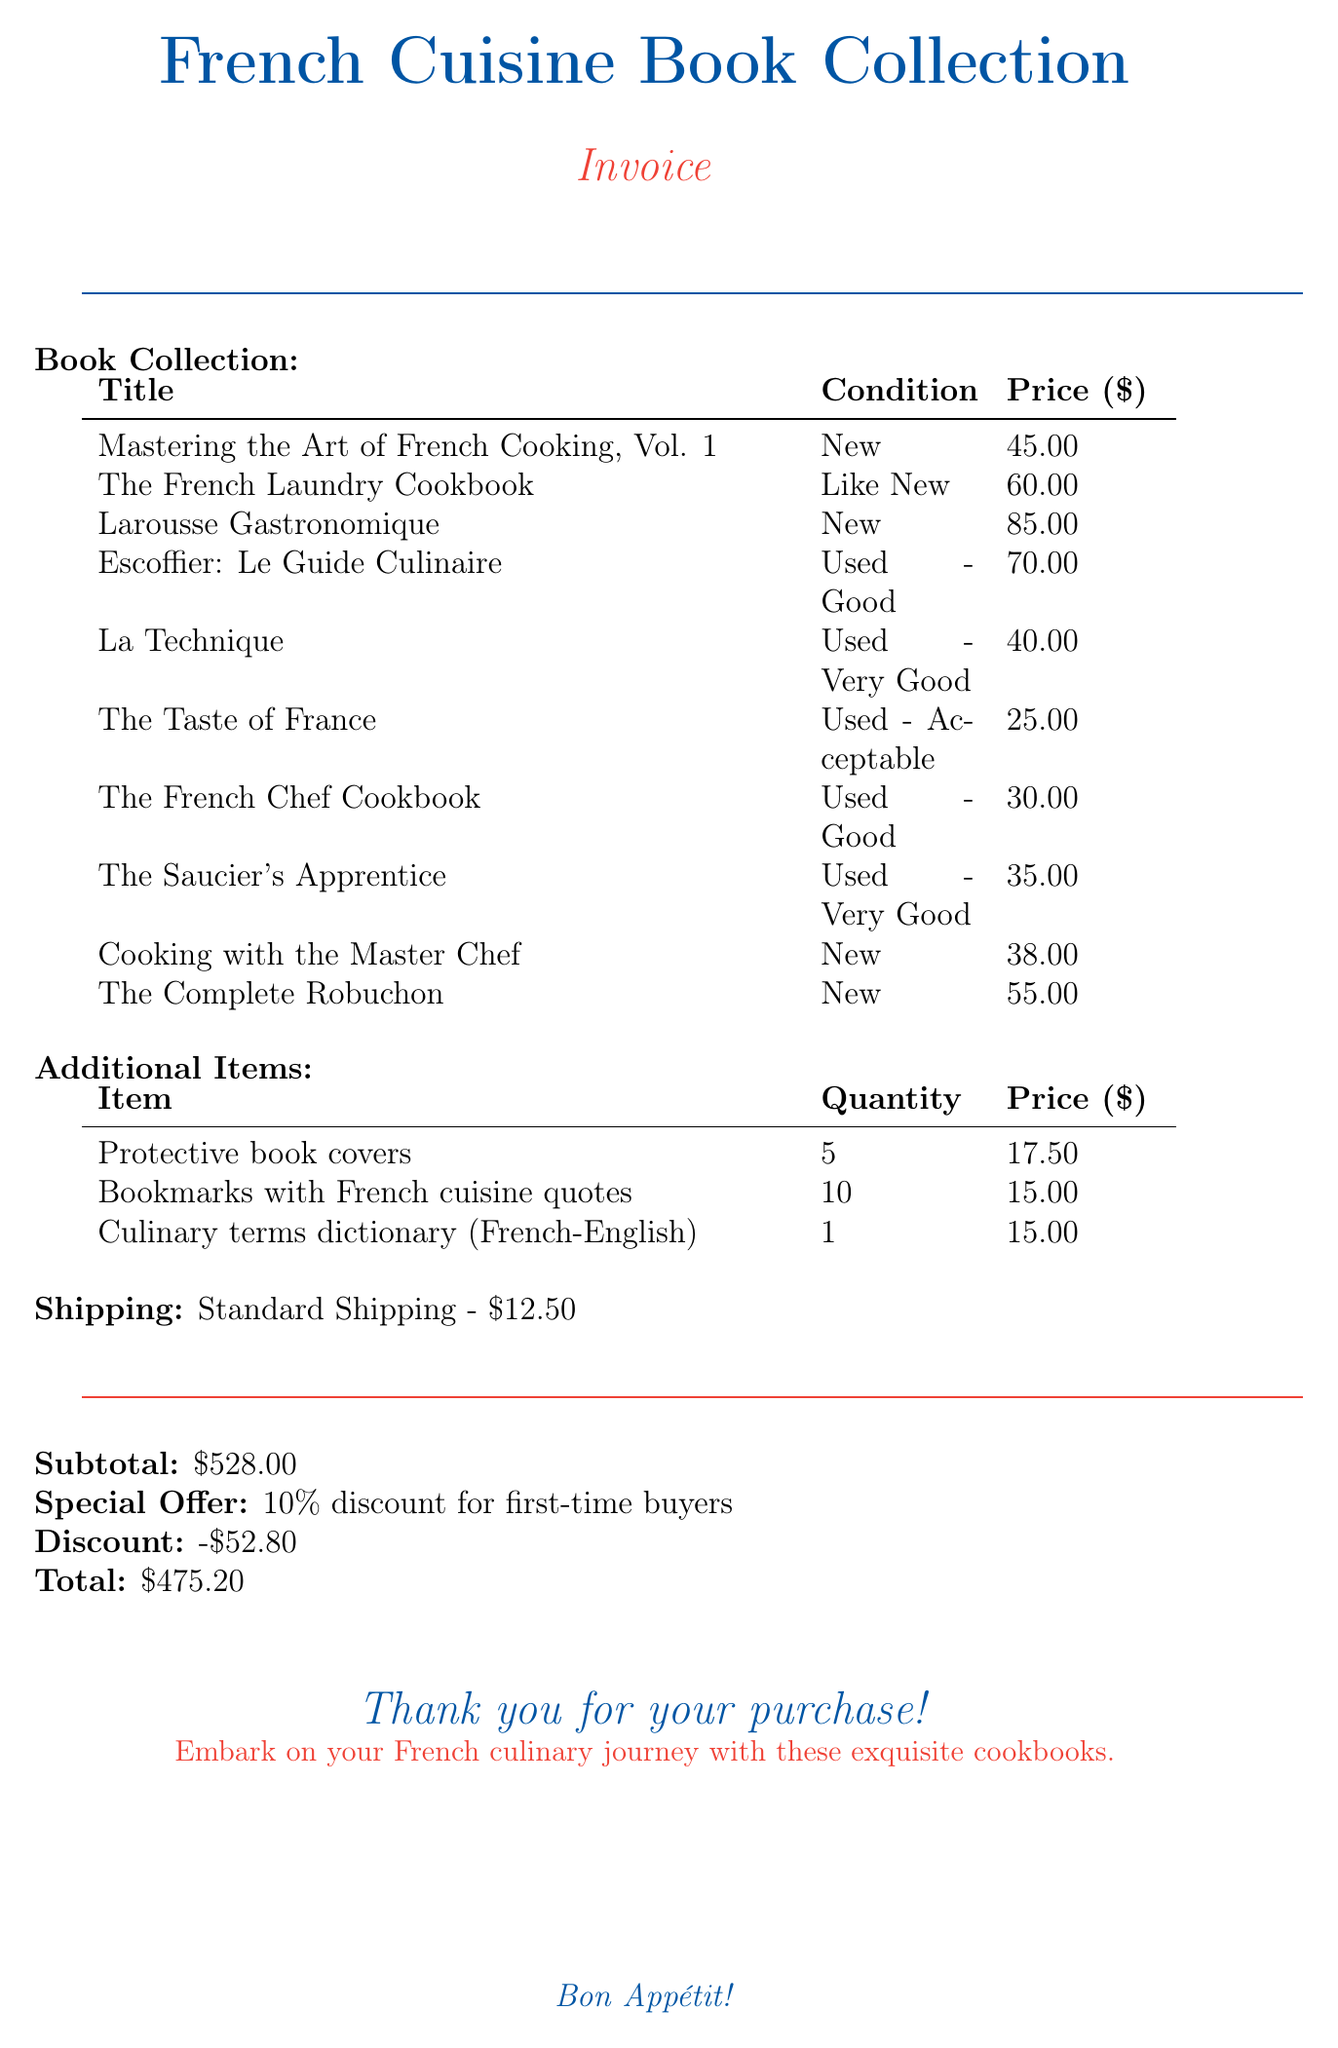What is the total amount of the invoice? The total amount is listed at the bottom of the invoice after applying the discount.
Answer: $475.20 Who is the author of "The French Laundry Cookbook"? The author of this book is mentioned in the specified invoice items section.
Answer: Thomas Keller How much is "Larousse Gastronomique"? The price of this book can be found in the book collection section of the document.
Answer: $85.00 What is the condition of "La Technique"? The condition of this book is provided in the document as part of the book collection details.
Answer: Used - Very Good How many protective book covers were purchased? This information is included in the additional items section of the invoice.
Answer: 5 What is the discount percentage for first-time buyers? The discount percentage is specified under the special offer section of the invoice.
Answer: 10% What is the shipping method used for the order? The shipping method can be found in the shipping section of the document.
Answer: Standard Shipping What item costs $1.50 each? This pricing detail is mentioned in the additional items section along with the quantity.
Answer: Bookmarks with French cuisine quotes How many books are listed in the invoice? The total number of books can be counted in the book collection section of the document.
Answer: 10 